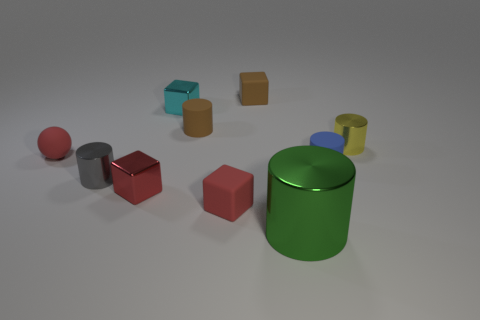Are there any other things that are the same size as the green shiny thing?
Ensure brevity in your answer.  No. What number of matte cylinders are the same size as the red metal block?
Make the answer very short. 2. How many big objects are red metal objects or red matte things?
Provide a short and direct response. 0. What number of small brown objects are there?
Keep it short and to the point. 2. Are there an equal number of rubber blocks that are right of the blue matte cylinder and red balls on the right side of the brown cube?
Your answer should be compact. Yes. Are there any tiny matte things in front of the tiny cyan object?
Keep it short and to the point. Yes. What is the color of the tiny object that is to the left of the small gray metal cylinder?
Ensure brevity in your answer.  Red. What is the material of the tiny brown thing that is behind the tiny brown rubber thing that is in front of the small cyan object?
Give a very brief answer. Rubber. Are there fewer red matte blocks that are behind the blue rubber thing than small matte cylinders on the right side of the big green thing?
Provide a succinct answer. Yes. What number of cyan things are tiny blocks or small things?
Your response must be concise. 1. 